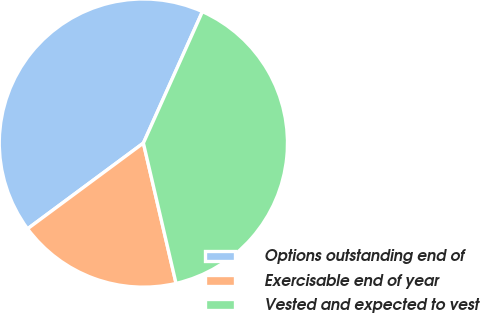Convert chart to OTSL. <chart><loc_0><loc_0><loc_500><loc_500><pie_chart><fcel>Options outstanding end of<fcel>Exercisable end of year<fcel>Vested and expected to vest<nl><fcel>41.86%<fcel>18.5%<fcel>39.64%<nl></chart> 